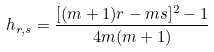<formula> <loc_0><loc_0><loc_500><loc_500>h _ { r , s } = \frac { [ ( m + 1 ) r - m s ] ^ { 2 } - 1 } { 4 m ( m + 1 ) }</formula> 